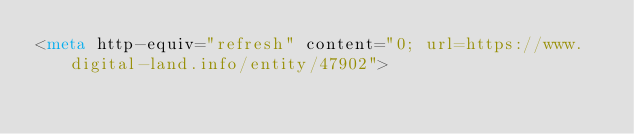<code> <loc_0><loc_0><loc_500><loc_500><_HTML_><meta http-equiv="refresh" content="0; url=https://www.digital-land.info/entity/47902"></code> 